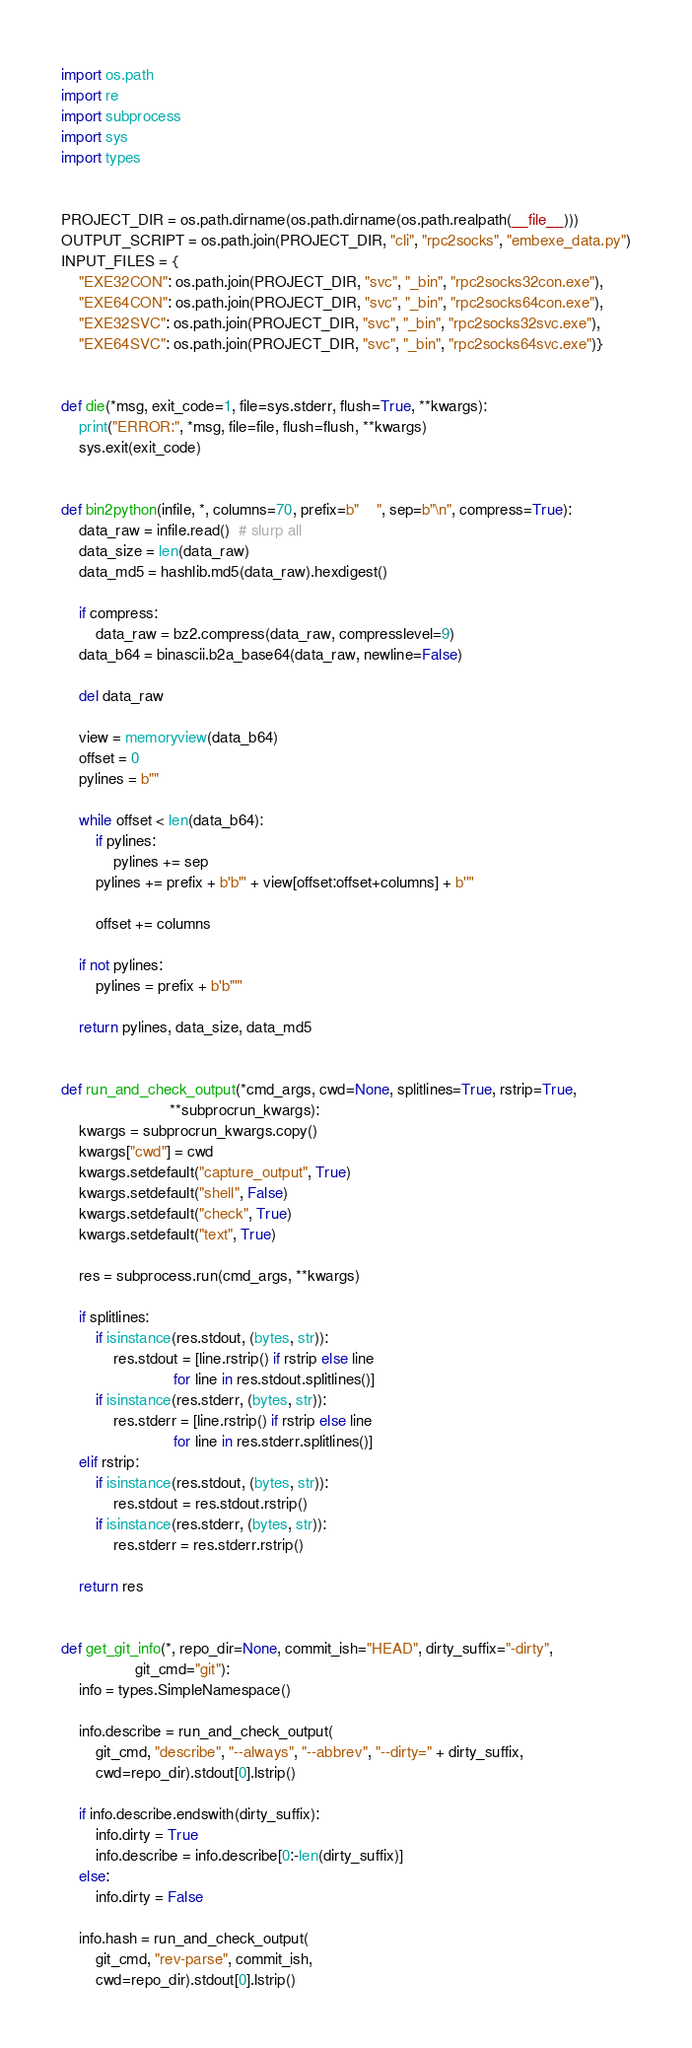<code> <loc_0><loc_0><loc_500><loc_500><_Python_>import os.path
import re
import subprocess
import sys
import types


PROJECT_DIR = os.path.dirname(os.path.dirname(os.path.realpath(__file__)))
OUTPUT_SCRIPT = os.path.join(PROJECT_DIR, "cli", "rpc2socks", "embexe_data.py")
INPUT_FILES = {
    "EXE32CON": os.path.join(PROJECT_DIR, "svc", "_bin", "rpc2socks32con.exe"),
    "EXE64CON": os.path.join(PROJECT_DIR, "svc", "_bin", "rpc2socks64con.exe"),
    "EXE32SVC": os.path.join(PROJECT_DIR, "svc", "_bin", "rpc2socks32svc.exe"),
    "EXE64SVC": os.path.join(PROJECT_DIR, "svc", "_bin", "rpc2socks64svc.exe")}


def die(*msg, exit_code=1, file=sys.stderr, flush=True, **kwargs):
    print("ERROR:", *msg, file=file, flush=flush, **kwargs)
    sys.exit(exit_code)


def bin2python(infile, *, columns=70, prefix=b"    ", sep=b"\n", compress=True):
    data_raw = infile.read()  # slurp all
    data_size = len(data_raw)
    data_md5 = hashlib.md5(data_raw).hexdigest()

    if compress:
        data_raw = bz2.compress(data_raw, compresslevel=9)
    data_b64 = binascii.b2a_base64(data_raw, newline=False)

    del data_raw

    view = memoryview(data_b64)
    offset = 0
    pylines = b""

    while offset < len(data_b64):
        if pylines:
            pylines += sep
        pylines += prefix + b'b"' + view[offset:offset+columns] + b'"'

        offset += columns

    if not pylines:
        pylines = prefix + b'b""'

    return pylines, data_size, data_md5


def run_and_check_output(*cmd_args, cwd=None, splitlines=True, rstrip=True,
                         **subprocrun_kwargs):
    kwargs = subprocrun_kwargs.copy()
    kwargs["cwd"] = cwd
    kwargs.setdefault("capture_output", True)
    kwargs.setdefault("shell", False)
    kwargs.setdefault("check", True)
    kwargs.setdefault("text", True)

    res = subprocess.run(cmd_args, **kwargs)

    if splitlines:
        if isinstance(res.stdout, (bytes, str)):
            res.stdout = [line.rstrip() if rstrip else line
                          for line in res.stdout.splitlines()]
        if isinstance(res.stderr, (bytes, str)):
            res.stderr = [line.rstrip() if rstrip else line
                          for line in res.stderr.splitlines()]
    elif rstrip:
        if isinstance(res.stdout, (bytes, str)):
            res.stdout = res.stdout.rstrip()
        if isinstance(res.stderr, (bytes, str)):
            res.stderr = res.stderr.rstrip()

    return res


def get_git_info(*, repo_dir=None, commit_ish="HEAD", dirty_suffix="-dirty",
                 git_cmd="git"):
    info = types.SimpleNamespace()

    info.describe = run_and_check_output(
        git_cmd, "describe", "--always", "--abbrev", "--dirty=" + dirty_suffix,
        cwd=repo_dir).stdout[0].lstrip()

    if info.describe.endswith(dirty_suffix):
        info.dirty = True
        info.describe = info.describe[0:-len(dirty_suffix)]
    else:
        info.dirty = False

    info.hash = run_and_check_output(
        git_cmd, "rev-parse", commit_ish,
        cwd=repo_dir).stdout[0].lstrip()</code> 